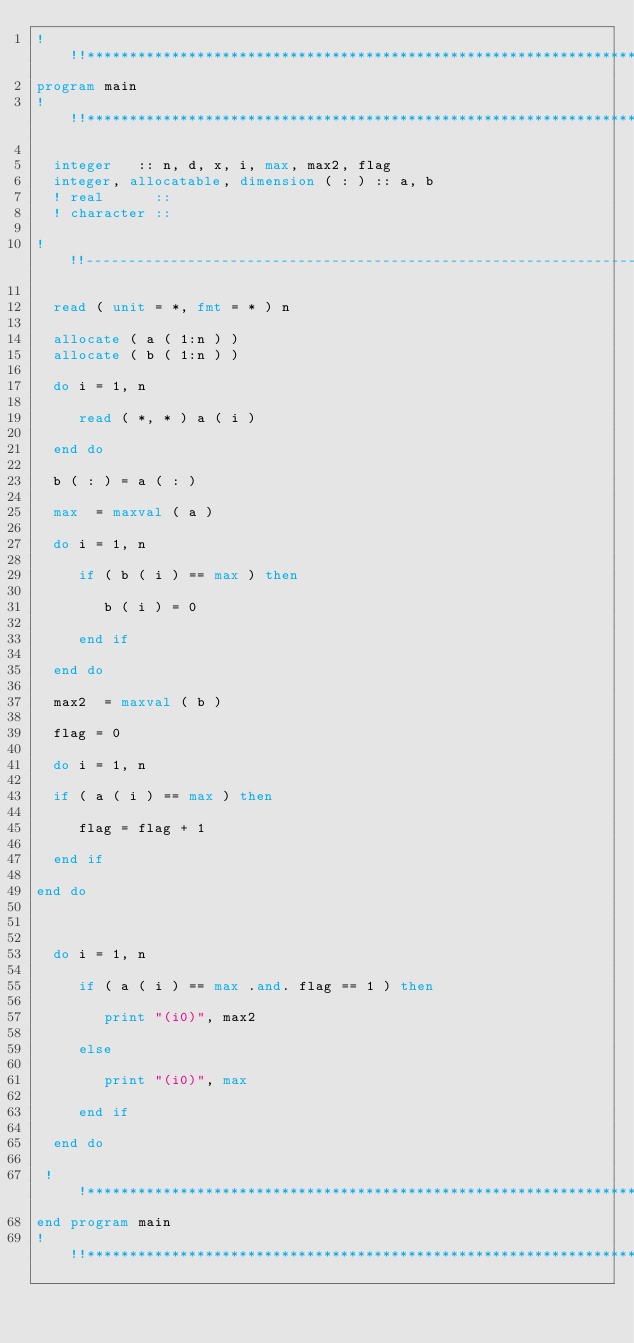<code> <loc_0><loc_0><loc_500><loc_500><_FORTRAN_>!!!**********************************************************************
program main
!!!**********************************************************************  

  integer   :: n, d, x, i, max, max2, flag
  integer, allocatable, dimension ( : ) :: a, b
  ! real      ::
  ! character ::
  
!!!----------------------------------------------------------------------

  read ( unit = *, fmt = * ) n

  allocate ( a ( 1:n ) )
  allocate ( b ( 1:n ) )  

  do i = 1, n

     read ( *, * ) a ( i )
     
  end do

  b ( : ) = a ( : )

  max  = maxval ( a )

  do i = 1, n

     if ( b ( i ) == max ) then

        b ( i ) = 0
        
     end if
     
  end do
 
  max2  = maxval ( b )

  flag = 0

  do i = 1, n       
  
  if ( a ( i ) == max ) then

     flag = flag + 1

  end if

end do

  
  
  do i = 1, n

     if ( a ( i ) == max .and. flag == 1 ) then

        print "(i0)", max2
        
     else 

        print "(i0)", max
        
     end if

  end do

 !!**********************************************************************  
end program main
!!!**********************************************************************
</code> 